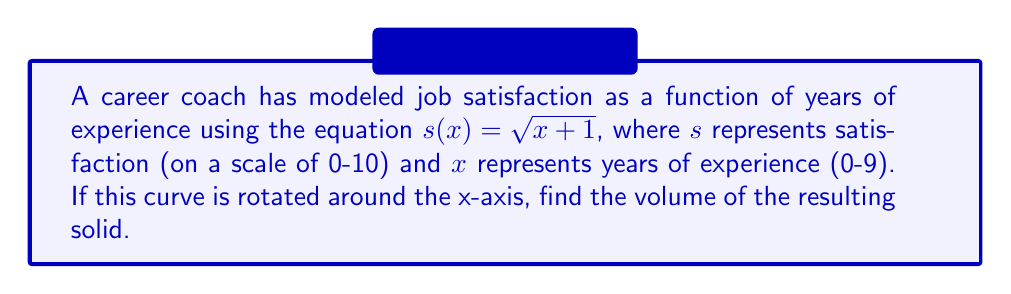Provide a solution to this math problem. To find the volume of a solid formed by rotating a curve around the x-axis, we use the disk method:

1) The volume is given by the integral:
   $$V = \pi \int_{a}^{b} [f(x)]^2 dx$$
   where $f(x)$ is the function being rotated, and $a$ and $b$ are the limits of integration.

2) In this case, $f(x) = s(x) = \sqrt{x+1}$, $a = 0$, and $b = 9$.

3) Substituting into the volume formula:
   $$V = \pi \int_{0}^{9} (\sqrt{x+1})^2 dx$$

4) Simplify the integrand:
   $$V = \pi \int_{0}^{9} (x+1) dx$$

5) Integrate:
   $$V = \pi [\frac{1}{2}x^2 + x]_{0}^{9}$$

6) Evaluate the integral:
   $$V = \pi [(\frac{1}{2}(9^2) + 9) - (\frac{1}{2}(0^2) + 0)]$$
   $$V = \pi [(40.5 + 9) - 0]$$
   $$V = \pi [49.5]$$

7) Simplify:
   $$V = 49.5\pi$$
Answer: $49.5\pi$ cubic units 